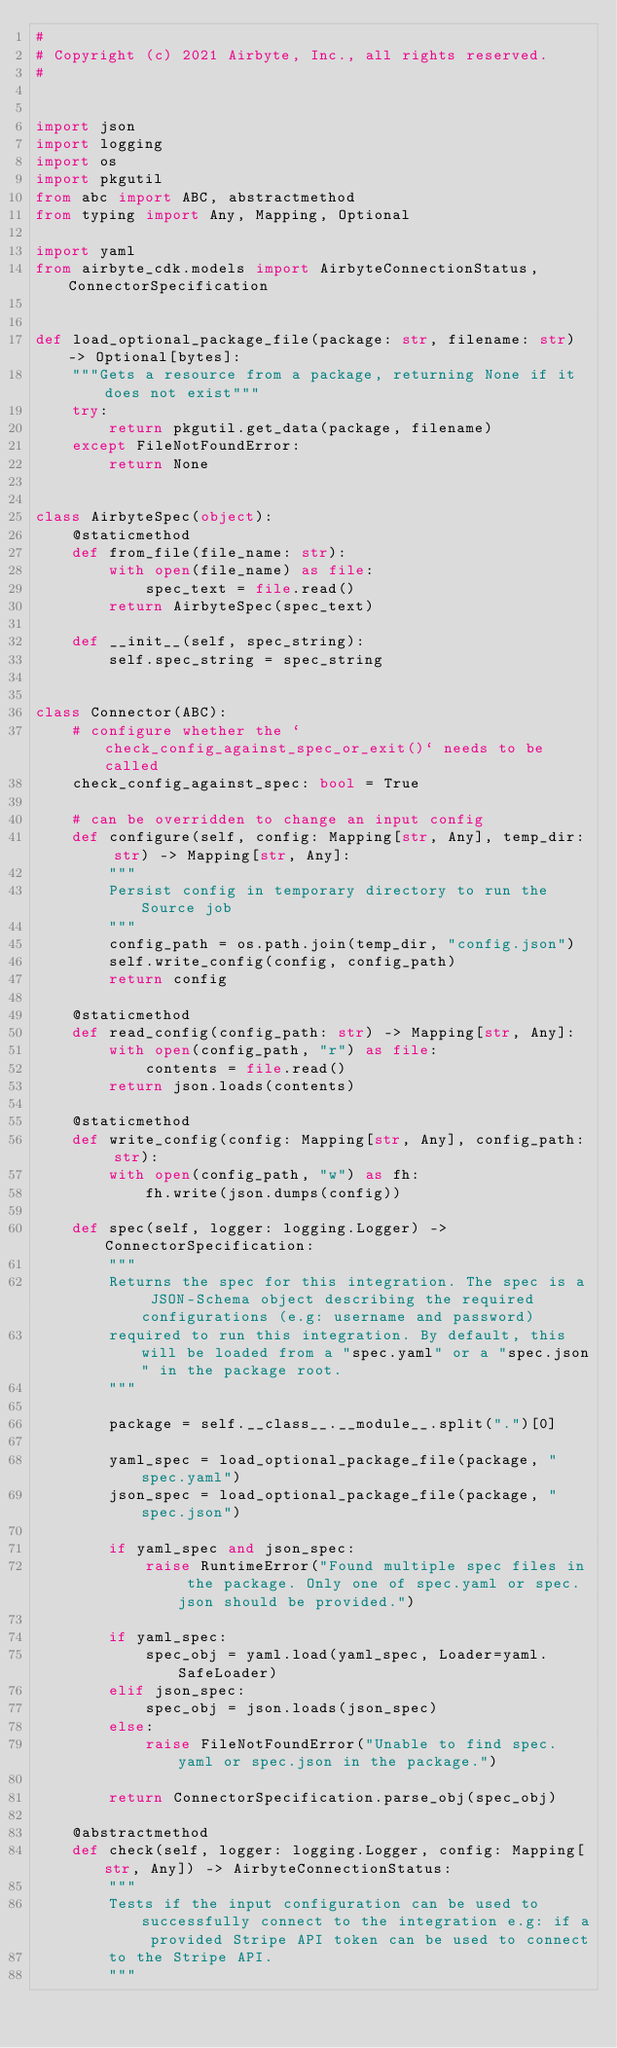Convert code to text. <code><loc_0><loc_0><loc_500><loc_500><_Python_>#
# Copyright (c) 2021 Airbyte, Inc., all rights reserved.
#


import json
import logging
import os
import pkgutil
from abc import ABC, abstractmethod
from typing import Any, Mapping, Optional

import yaml
from airbyte_cdk.models import AirbyteConnectionStatus, ConnectorSpecification


def load_optional_package_file(package: str, filename: str) -> Optional[bytes]:
    """Gets a resource from a package, returning None if it does not exist"""
    try:
        return pkgutil.get_data(package, filename)
    except FileNotFoundError:
        return None


class AirbyteSpec(object):
    @staticmethod
    def from_file(file_name: str):
        with open(file_name) as file:
            spec_text = file.read()
        return AirbyteSpec(spec_text)

    def __init__(self, spec_string):
        self.spec_string = spec_string


class Connector(ABC):
    # configure whether the `check_config_against_spec_or_exit()` needs to be called
    check_config_against_spec: bool = True

    # can be overridden to change an input config
    def configure(self, config: Mapping[str, Any], temp_dir: str) -> Mapping[str, Any]:
        """
        Persist config in temporary directory to run the Source job
        """
        config_path = os.path.join(temp_dir, "config.json")
        self.write_config(config, config_path)
        return config

    @staticmethod
    def read_config(config_path: str) -> Mapping[str, Any]:
        with open(config_path, "r") as file:
            contents = file.read()
        return json.loads(contents)

    @staticmethod
    def write_config(config: Mapping[str, Any], config_path: str):
        with open(config_path, "w") as fh:
            fh.write(json.dumps(config))

    def spec(self, logger: logging.Logger) -> ConnectorSpecification:
        """
        Returns the spec for this integration. The spec is a JSON-Schema object describing the required configurations (e.g: username and password)
        required to run this integration. By default, this will be loaded from a "spec.yaml" or a "spec.json" in the package root.
        """

        package = self.__class__.__module__.split(".")[0]

        yaml_spec = load_optional_package_file(package, "spec.yaml")
        json_spec = load_optional_package_file(package, "spec.json")

        if yaml_spec and json_spec:
            raise RuntimeError("Found multiple spec files in the package. Only one of spec.yaml or spec.json should be provided.")

        if yaml_spec:
            spec_obj = yaml.load(yaml_spec, Loader=yaml.SafeLoader)
        elif json_spec:
            spec_obj = json.loads(json_spec)
        else:
            raise FileNotFoundError("Unable to find spec.yaml or spec.json in the package.")

        return ConnectorSpecification.parse_obj(spec_obj)

    @abstractmethod
    def check(self, logger: logging.Logger, config: Mapping[str, Any]) -> AirbyteConnectionStatus:
        """
        Tests if the input configuration can be used to successfully connect to the integration e.g: if a provided Stripe API token can be used to connect
        to the Stripe API.
        """
</code> 